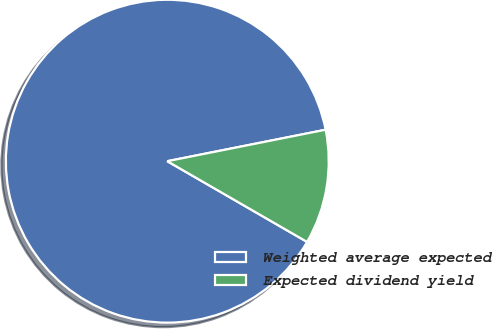Convert chart. <chart><loc_0><loc_0><loc_500><loc_500><pie_chart><fcel>Weighted average expected<fcel>Expected dividend yield<nl><fcel>88.54%<fcel>11.46%<nl></chart> 